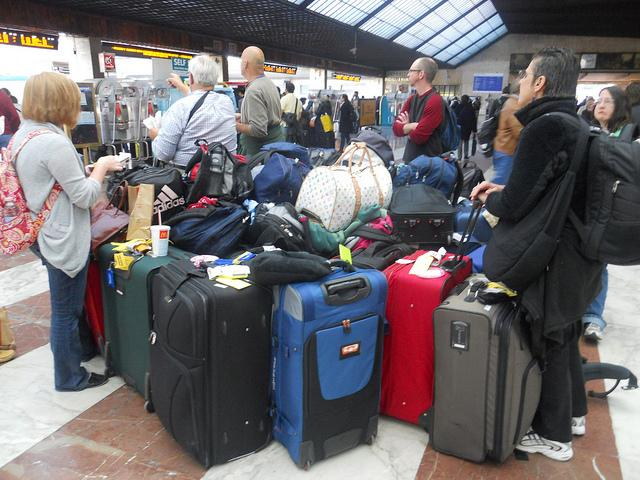What activity are these people engaged in?

Choices:
A) sport
B) travel
C) debate
D) celebration travel 